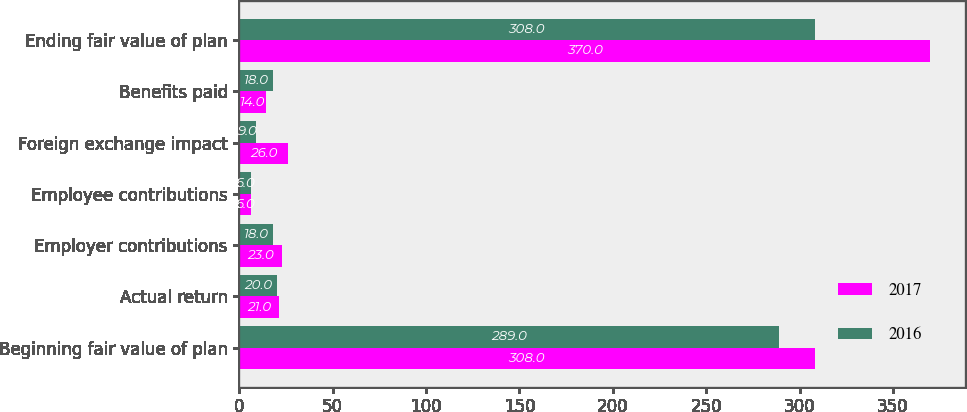Convert chart to OTSL. <chart><loc_0><loc_0><loc_500><loc_500><stacked_bar_chart><ecel><fcel>Beginning fair value of plan<fcel>Actual return<fcel>Employer contributions<fcel>Employee contributions<fcel>Foreign exchange impact<fcel>Benefits paid<fcel>Ending fair value of plan<nl><fcel>2017<fcel>308<fcel>21<fcel>23<fcel>6<fcel>26<fcel>14<fcel>370<nl><fcel>2016<fcel>289<fcel>20<fcel>18<fcel>6<fcel>9<fcel>18<fcel>308<nl></chart> 